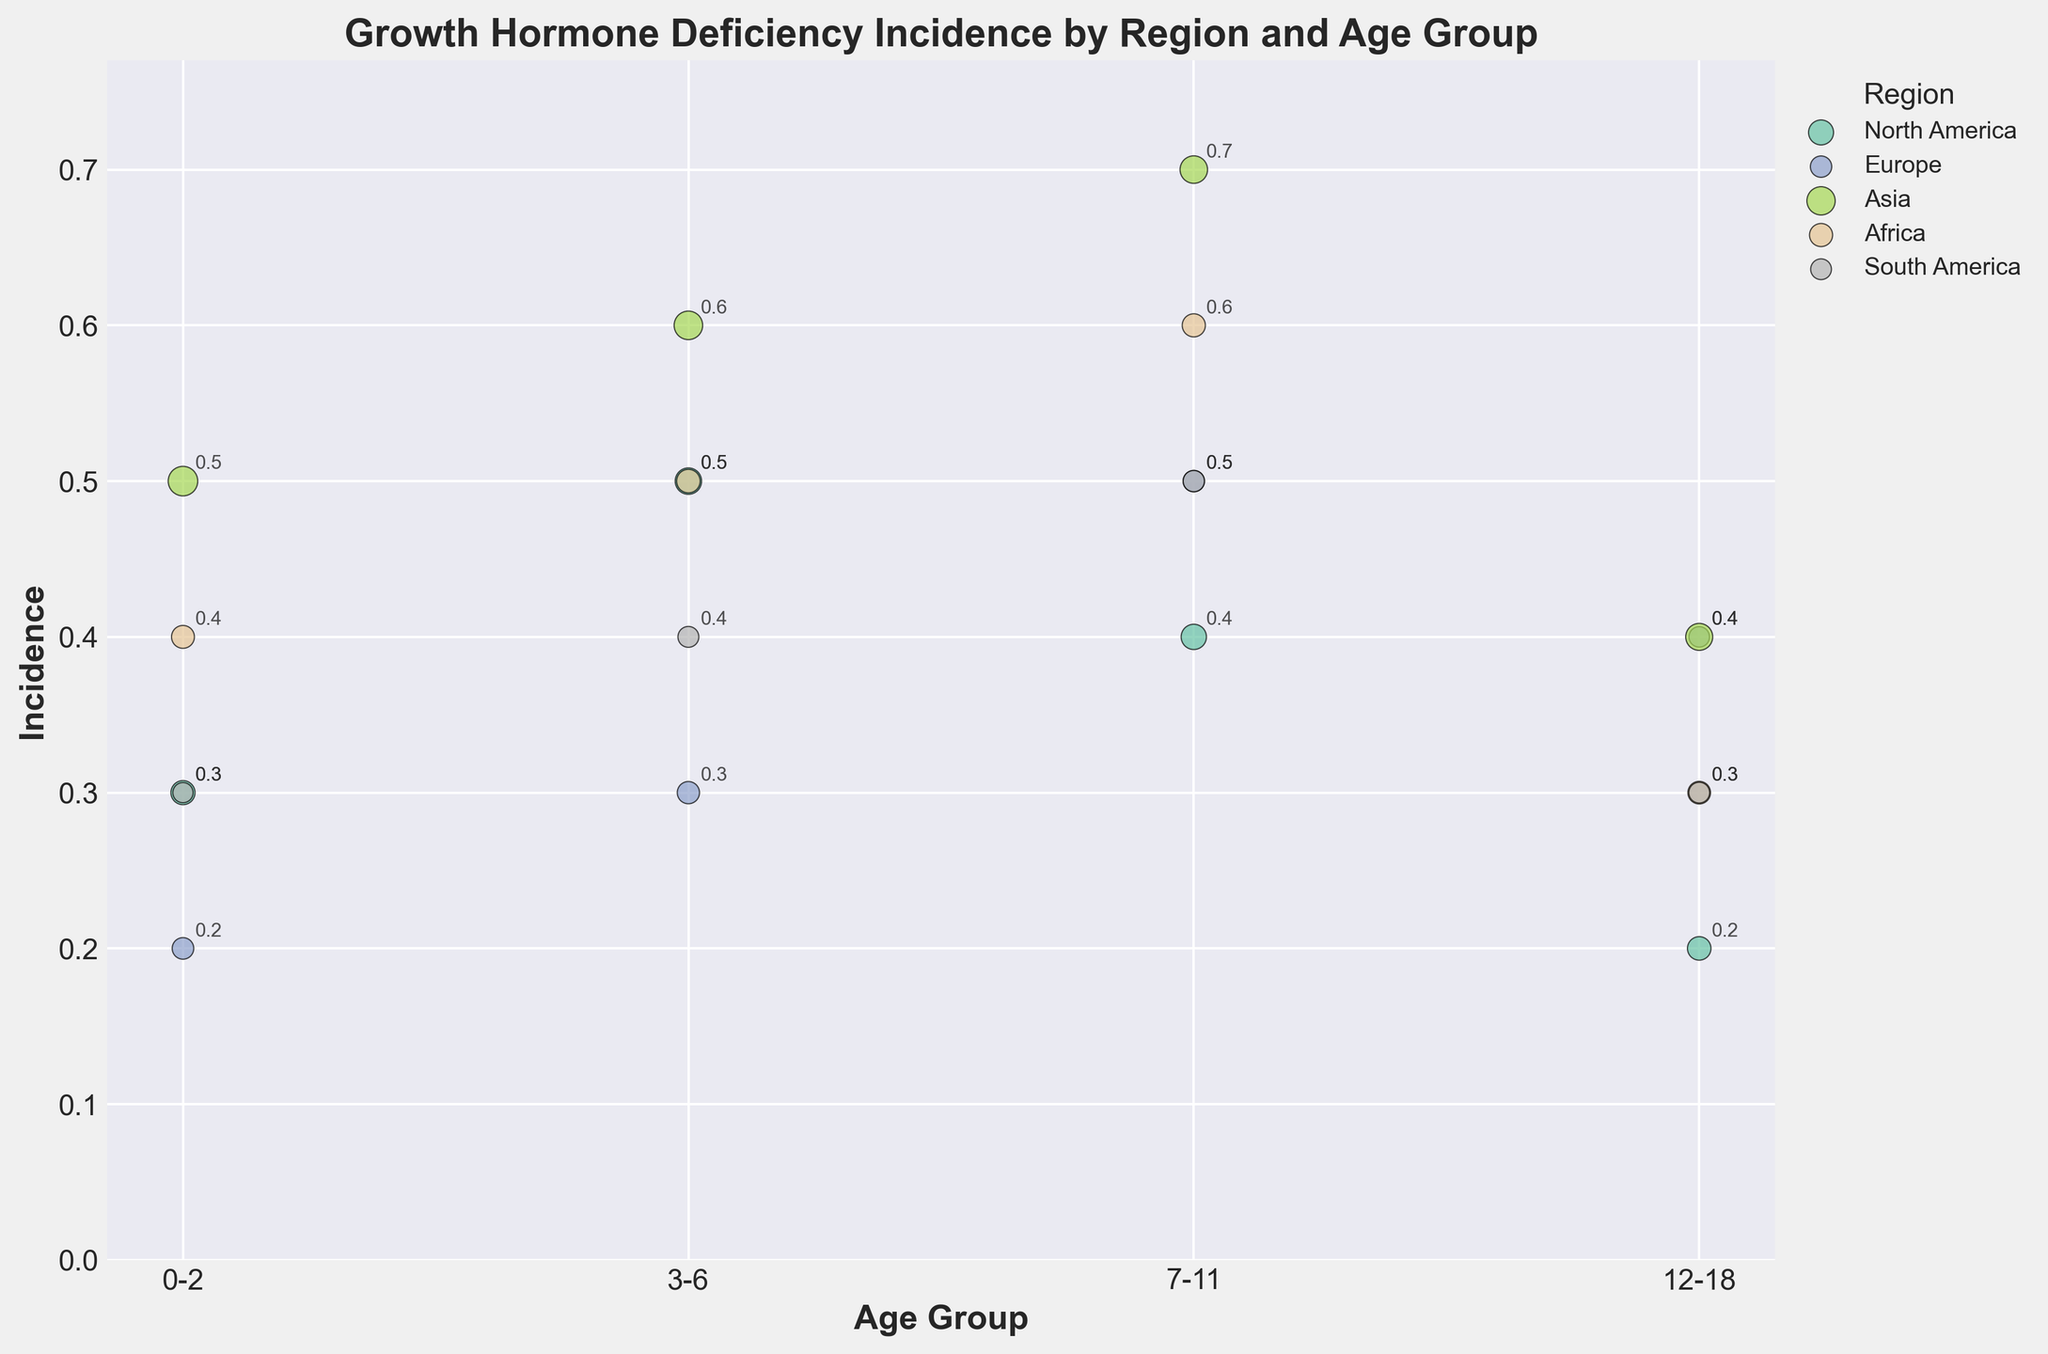What's the title of the figure? The title of the figure is usually displayed at the top. Upon looking at the figure, the title is "Growth Hormone Deficiency Incidence by Region and Age Group".
Answer: Growth Hormone Deficiency Incidence by Region and Age Group Which region has the highest incidence rate for the 7-11 age group? To determine the highest incidence rate for the 7-11 age group, observe the y-axis values and find the bubble with the highest value within the 7-11 age group marks. In this case, Asia has the highest incidence rate of 0.7.
Answer: Asia What is the incidence rate for the 3-6 age group in Europe? Locate the bubble for Europe in the 3-6 age group along the x-axis and check its corresponding incidence rate on the y-axis. The incidence rate for Europe in the 3-6 age group is 0.3.
Answer: 0.3 Which region has the largest population for the 0-2 age group? The bubble size represents the population. In the 0-2 age group, the largest bubble corresponds to the region with the largest population. Asia has the largest bubble in the 0-2 age group, indicating the largest population.
Answer: Asia Between North America and Africa, which region shows a higher incidence rate for the 12-18 age group? Compare the y-values of the bubbles representing North America and Africa in the 12-18 age group. North America's incidence rate is 0.2 and Africa's is 0.3, making Africa higher.
Answer: Africa What is the sum of incidence rates for Europe across all age groups? Add the incidence rates for Europe across all age groups: 0.2 (0-2) + 0.3 (3-6) + 0.5 (7-11) + 0.4 (12-18). The total is 0.2 + 0.3 + 0.5 + 0.4 = 1.4.
Answer: 1.4 Which age group in South America has the lowest incidence rate? Examine the bubbles for South America and note the y-value for each age group. The lowest incidence rate is found in the 12-18 age group, which is 0.3.
Answer: 12-18 In which region do we see the highest incidence for the 0-2 age group, and what is the value? Identify the highest y-value in the 0-2 age group bubbles, which is seen in Asia with an incidence rate of 0.5.
Answer: Asia, 0.5 What is the average incidence rate for the 3-6 age group across all regions? Calculate the average by adding the incidence rates of the 3-6 age group for all regions and then dividing by the number of regions. (0.5 + 0.3 + 0.6 + 0.5 + 0.4) / 5 = 2.3 / 5 = 0.46.
Answer: 0.46 How does the incidence rate of the 7-11 age group in Africa compare to the 7-11 age group in South America? Compare the y-values of the bubbles for the 7-11 age group in Africa (0.6) and South America (0.5). Africa's rate is higher.
Answer: Africa is higher 